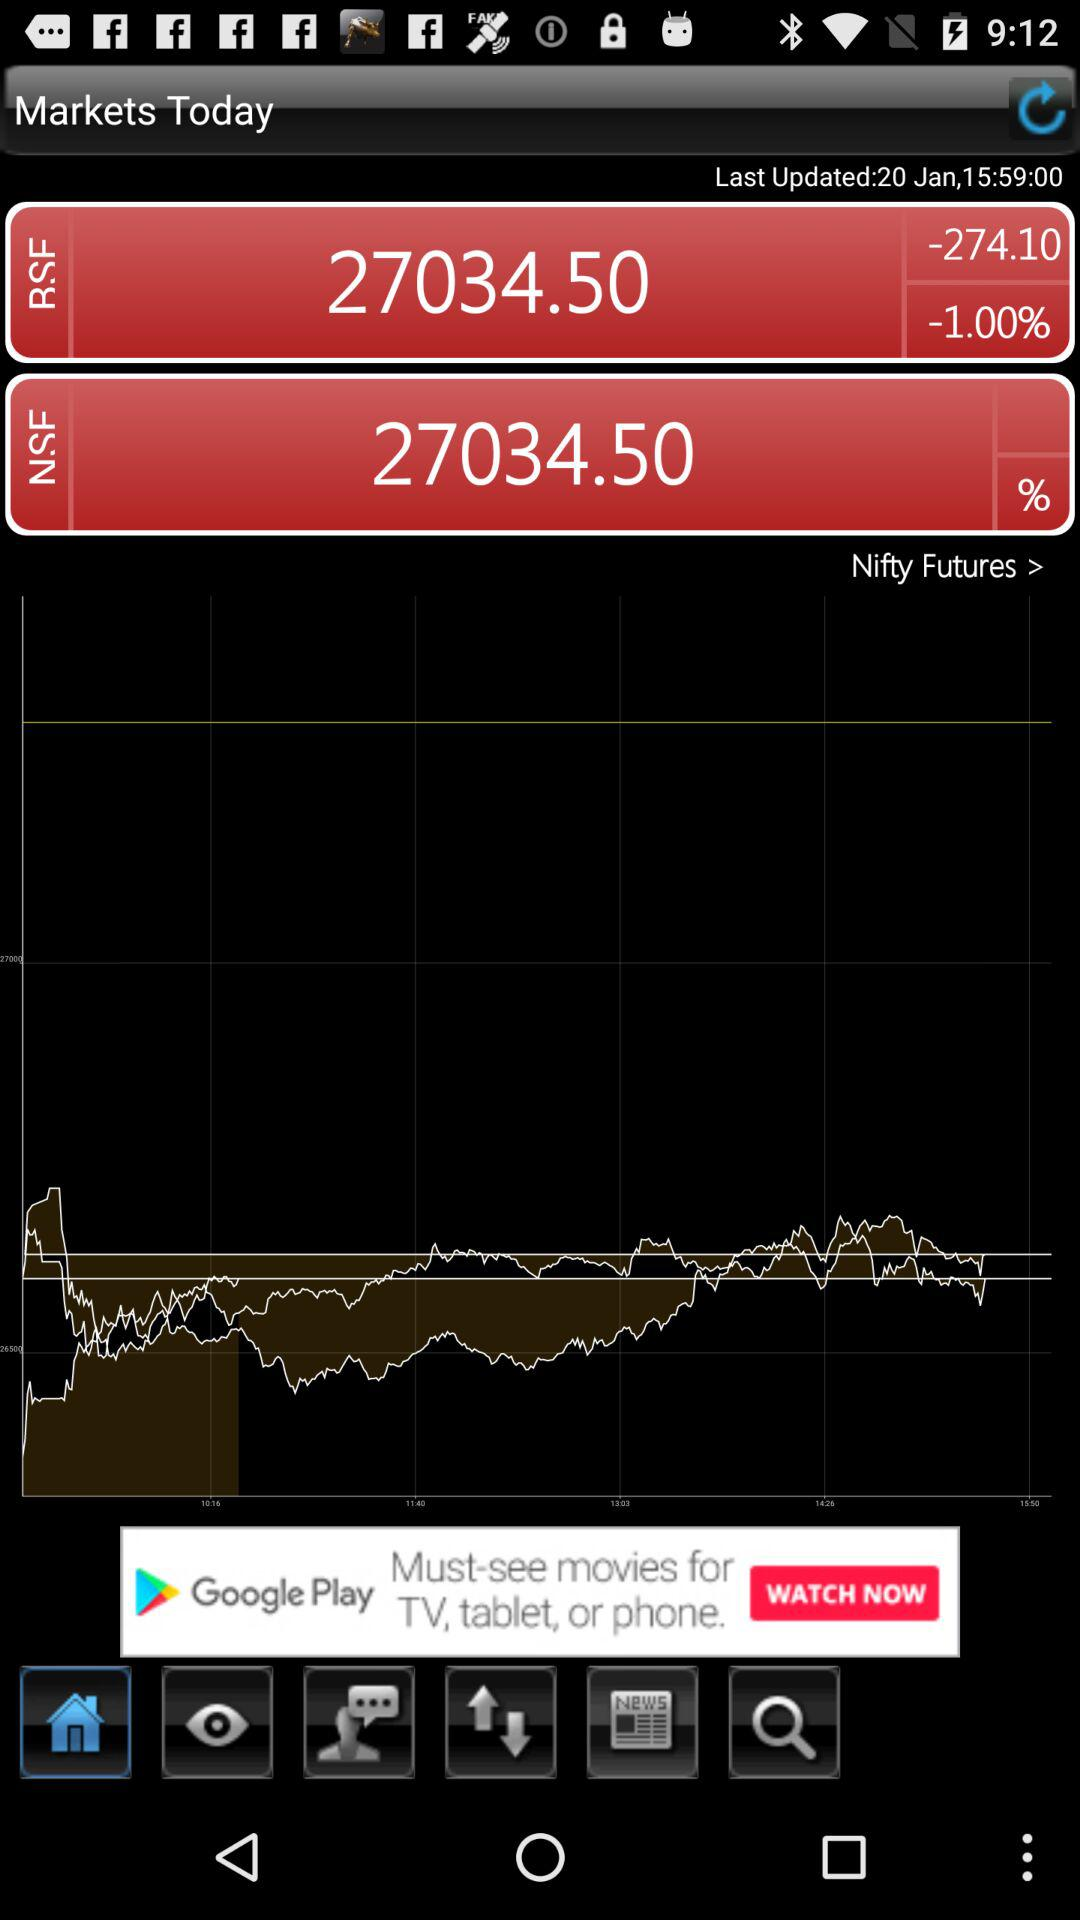How many more points is the BSE value than the NSE value?
Answer the question using a single word or phrase. 0 